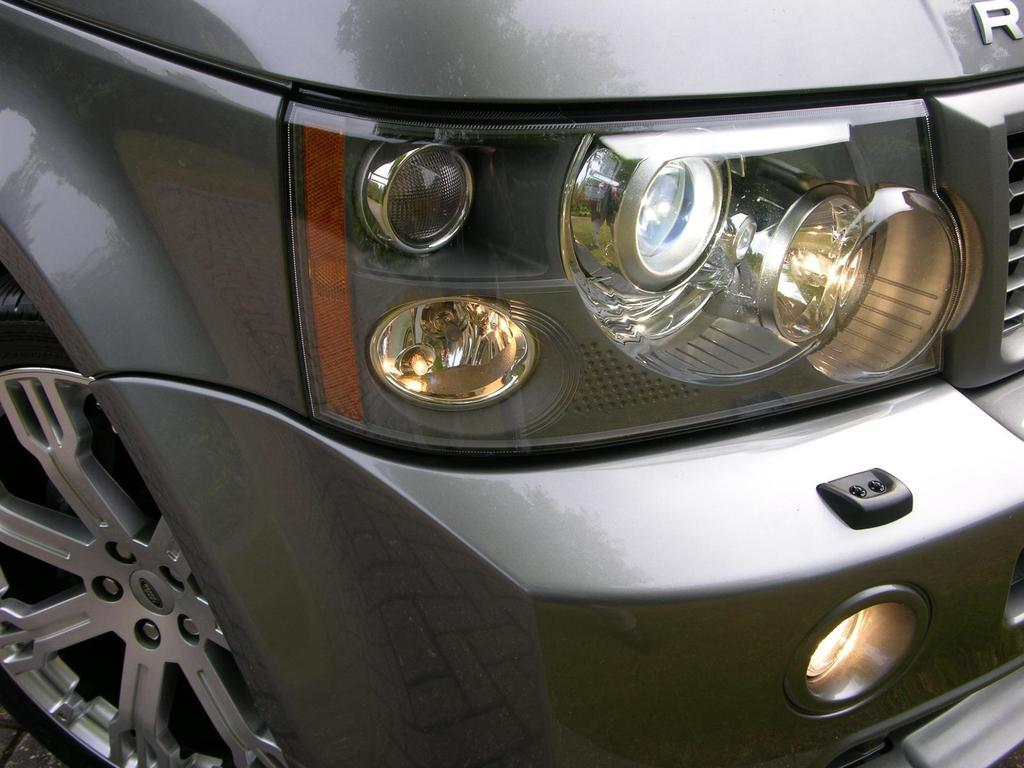What is the main subject of the image? The main subject of the image is a vehicle. What specific features can be seen on the vehicle? The vehicle has headlights and wheels. What surface is visible in the image? There is a floor visible in the image. Can you hear the bell ringing in the image? There is no bell present in the image, so it cannot be heard ringing. 